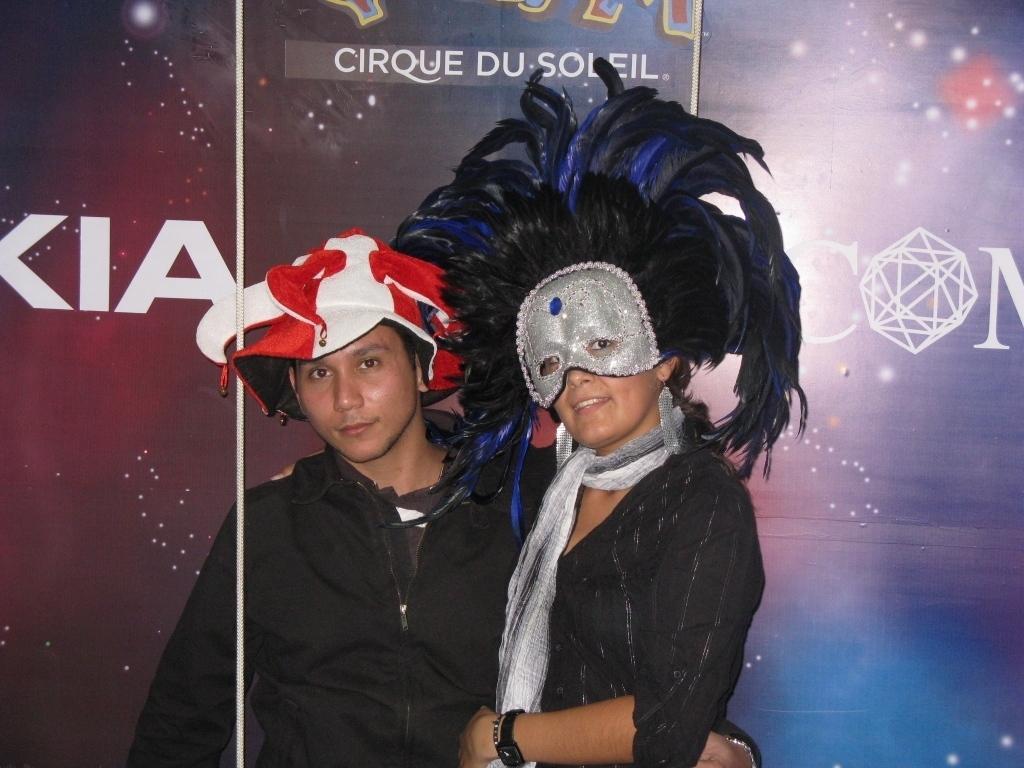Can you describe this image briefly? In this image we can see a man wearing the cap. We can also see the woman with the face mask. In the background, we can see the banner with the text. 